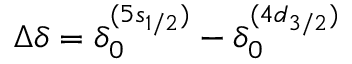Convert formula to latex. <formula><loc_0><loc_0><loc_500><loc_500>\Delta \delta = \delta _ { 0 } ^ { ( 5 s _ { 1 / 2 } ) } - \delta _ { 0 } ^ { ( 4 d _ { 3 / 2 } ) }</formula> 